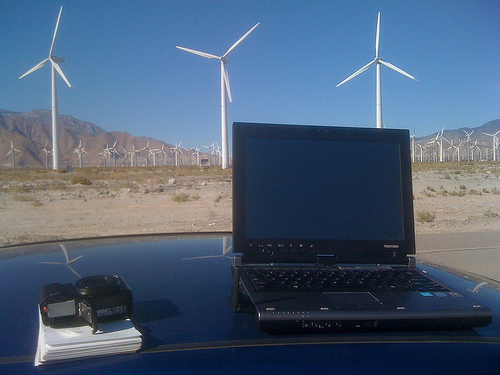<image>
Is there a windmill on the laptop? No. The windmill is not positioned on the laptop. They may be near each other, but the windmill is not supported by or resting on top of the laptop. Is the camera behind the laptop? No. The camera is not behind the laptop. From this viewpoint, the camera appears to be positioned elsewhere in the scene. Where is the computer in relation to the windmill? Is it in front of the windmill? Yes. The computer is positioned in front of the windmill, appearing closer to the camera viewpoint. Is the windmill above the laptop? No. The windmill is not positioned above the laptop. The vertical arrangement shows a different relationship. 